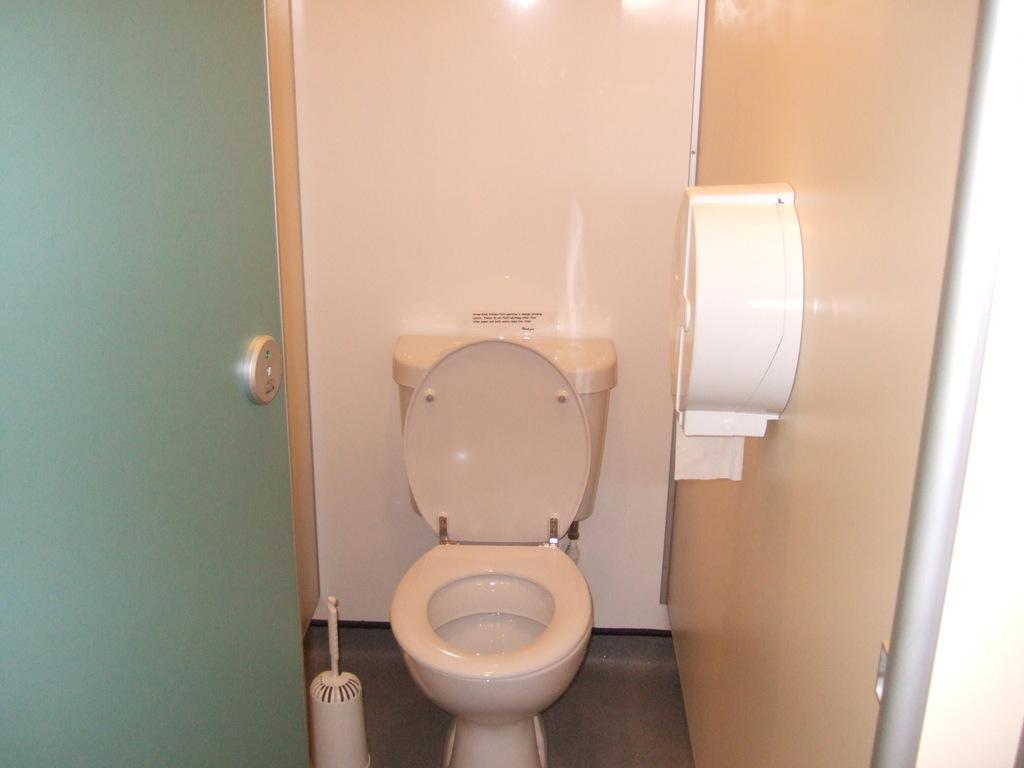In one or two sentences, can you explain what this image depicts? In this image I can see a toilet seat. Here I can see a door. On the right side I can see a wall which a white color object attached to it. 